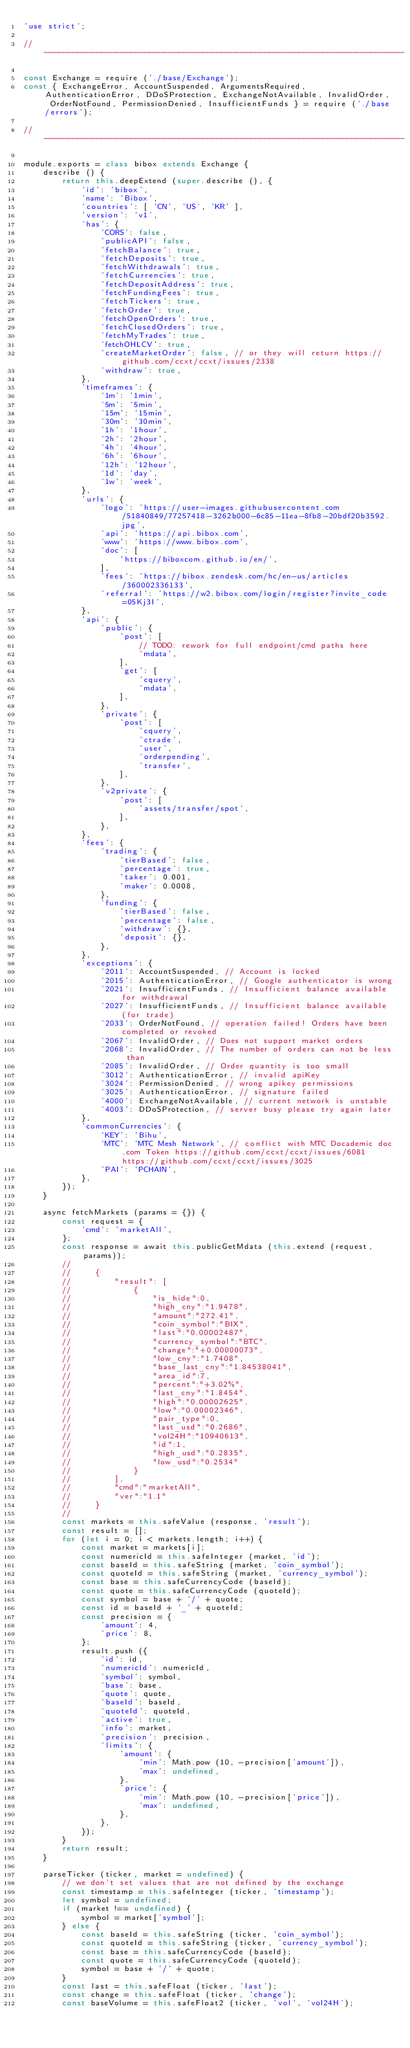Convert code to text. <code><loc_0><loc_0><loc_500><loc_500><_JavaScript_>'use strict';

//  ---------------------------------------------------------------------------

const Exchange = require ('./base/Exchange');
const { ExchangeError, AccountSuspended, ArgumentsRequired, AuthenticationError, DDoSProtection, ExchangeNotAvailable, InvalidOrder, OrderNotFound, PermissionDenied, InsufficientFunds } = require ('./base/errors');

//  ---------------------------------------------------------------------------

module.exports = class bibox extends Exchange {
    describe () {
        return this.deepExtend (super.describe (), {
            'id': 'bibox',
            'name': 'Bibox',
            'countries': [ 'CN', 'US', 'KR' ],
            'version': 'v1',
            'has': {
                'CORS': false,
                'publicAPI': false,
                'fetchBalance': true,
                'fetchDeposits': true,
                'fetchWithdrawals': true,
                'fetchCurrencies': true,
                'fetchDepositAddress': true,
                'fetchFundingFees': true,
                'fetchTickers': true,
                'fetchOrder': true,
                'fetchOpenOrders': true,
                'fetchClosedOrders': true,
                'fetchMyTrades': true,
                'fetchOHLCV': true,
                'createMarketOrder': false, // or they will return https://github.com/ccxt/ccxt/issues/2338
                'withdraw': true,
            },
            'timeframes': {
                '1m': '1min',
                '5m': '5min',
                '15m': '15min',
                '30m': '30min',
                '1h': '1hour',
                '2h': '2hour',
                '4h': '4hour',
                '6h': '6hour',
                '12h': '12hour',
                '1d': 'day',
                '1w': 'week',
            },
            'urls': {
                'logo': 'https://user-images.githubusercontent.com/51840849/77257418-3262b000-6c85-11ea-8fb8-20bdf20b3592.jpg',
                'api': 'https://api.bibox.com',
                'www': 'https://www.bibox.com',
                'doc': [
                    'https://biboxcom.github.io/en/',
                ],
                'fees': 'https://bibox.zendesk.com/hc/en-us/articles/360002336133',
                'referral': 'https://w2.bibox.com/login/register?invite_code=05Kj3I',
            },
            'api': {
                'public': {
                    'post': [
                        // TODO: rework for full endpoint/cmd paths here
                        'mdata',
                    ],
                    'get': [
                        'cquery',
                        'mdata',
                    ],
                },
                'private': {
                    'post': [
                        'cquery',
                        'ctrade',
                        'user',
                        'orderpending',
                        'transfer',
                    ],
                },
                'v2private': {
                    'post': [
                        'assets/transfer/spot',
                    ],
                },
            },
            'fees': {
                'trading': {
                    'tierBased': false,
                    'percentage': true,
                    'taker': 0.001,
                    'maker': 0.0008,
                },
                'funding': {
                    'tierBased': false,
                    'percentage': false,
                    'withdraw': {},
                    'deposit': {},
                },
            },
            'exceptions': {
                '2011': AccountSuspended, // Account is locked
                '2015': AuthenticationError, // Google authenticator is wrong
                '2021': InsufficientFunds, // Insufficient balance available for withdrawal
                '2027': InsufficientFunds, // Insufficient balance available (for trade)
                '2033': OrderNotFound, // operation failed! Orders have been completed or revoked
                '2067': InvalidOrder, // Does not support market orders
                '2068': InvalidOrder, // The number of orders can not be less than
                '2085': InvalidOrder, // Order quantity is too small
                '3012': AuthenticationError, // invalid apiKey
                '3024': PermissionDenied, // wrong apikey permissions
                '3025': AuthenticationError, // signature failed
                '4000': ExchangeNotAvailable, // current network is unstable
                '4003': DDoSProtection, // server busy please try again later
            },
            'commonCurrencies': {
                'KEY': 'Bihu',
                'MTC': 'MTC Mesh Network', // conflict with MTC Docademic doc.com Token https://github.com/ccxt/ccxt/issues/6081 https://github.com/ccxt/ccxt/issues/3025
                'PAI': 'PCHAIN',
            },
        });
    }

    async fetchMarkets (params = {}) {
        const request = {
            'cmd': 'marketAll',
        };
        const response = await this.publicGetMdata (this.extend (request, params));
        //
        //     {
        //         "result": [
        //             {
        //                 "is_hide":0,
        //                 "high_cny":"1.9478",
        //                 "amount":"272.41",
        //                 "coin_symbol":"BIX",
        //                 "last":"0.00002487",
        //                 "currency_symbol":"BTC",
        //                 "change":"+0.00000073",
        //                 "low_cny":"1.7408",
        //                 "base_last_cny":"1.84538041",
        //                 "area_id":7,
        //                 "percent":"+3.02%",
        //                 "last_cny":"1.8454",
        //                 "high":"0.00002625",
        //                 "low":"0.00002346",
        //                 "pair_type":0,
        //                 "last_usd":"0.2686",
        //                 "vol24H":"10940613",
        //                 "id":1,
        //                 "high_usd":"0.2835",
        //                 "low_usd":"0.2534"
        //             }
        //         ],
        //         "cmd":"marketAll",
        //         "ver":"1.1"
        //     }
        //
        const markets = this.safeValue (response, 'result');
        const result = [];
        for (let i = 0; i < markets.length; i++) {
            const market = markets[i];
            const numericId = this.safeInteger (market, 'id');
            const baseId = this.safeString (market, 'coin_symbol');
            const quoteId = this.safeString (market, 'currency_symbol');
            const base = this.safeCurrencyCode (baseId);
            const quote = this.safeCurrencyCode (quoteId);
            const symbol = base + '/' + quote;
            const id = baseId + '_' + quoteId;
            const precision = {
                'amount': 4,
                'price': 8,
            };
            result.push ({
                'id': id,
                'numericId': numericId,
                'symbol': symbol,
                'base': base,
                'quote': quote,
                'baseId': baseId,
                'quoteId': quoteId,
                'active': true,
                'info': market,
                'precision': precision,
                'limits': {
                    'amount': {
                        'min': Math.pow (10, -precision['amount']),
                        'max': undefined,
                    },
                    'price': {
                        'min': Math.pow (10, -precision['price']),
                        'max': undefined,
                    },
                },
            });
        }
        return result;
    }

    parseTicker (ticker, market = undefined) {
        // we don't set values that are not defined by the exchange
        const timestamp = this.safeInteger (ticker, 'timestamp');
        let symbol = undefined;
        if (market !== undefined) {
            symbol = market['symbol'];
        } else {
            const baseId = this.safeString (ticker, 'coin_symbol');
            const quoteId = this.safeString (ticker, 'currency_symbol');
            const base = this.safeCurrencyCode (baseId);
            const quote = this.safeCurrencyCode (quoteId);
            symbol = base + '/' + quote;
        }
        const last = this.safeFloat (ticker, 'last');
        const change = this.safeFloat (ticker, 'change');
        const baseVolume = this.safeFloat2 (ticker, 'vol', 'vol24H');</code> 